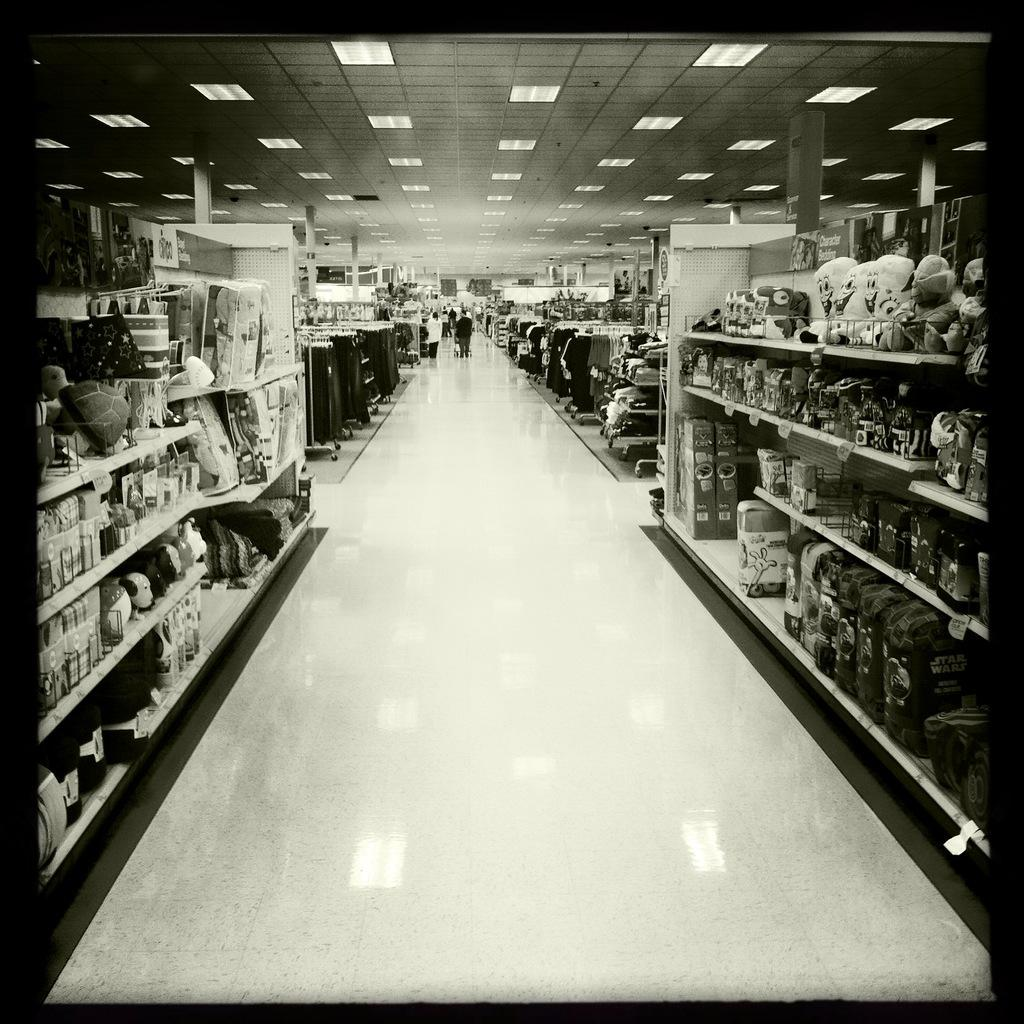Where was the image taken? The image was taken inside a shopping mall. What can be seen in the image besides the shopping mall setting? There are different racks in the image, with many things present on the racks. What is the color of the floor in the image? The floor is white in color. Can you see a giraffe walking around in the shopping mall in the image? No, there is no giraffe present in the image. Are there any giants visible in the image? No, there are no giants present in the image. 